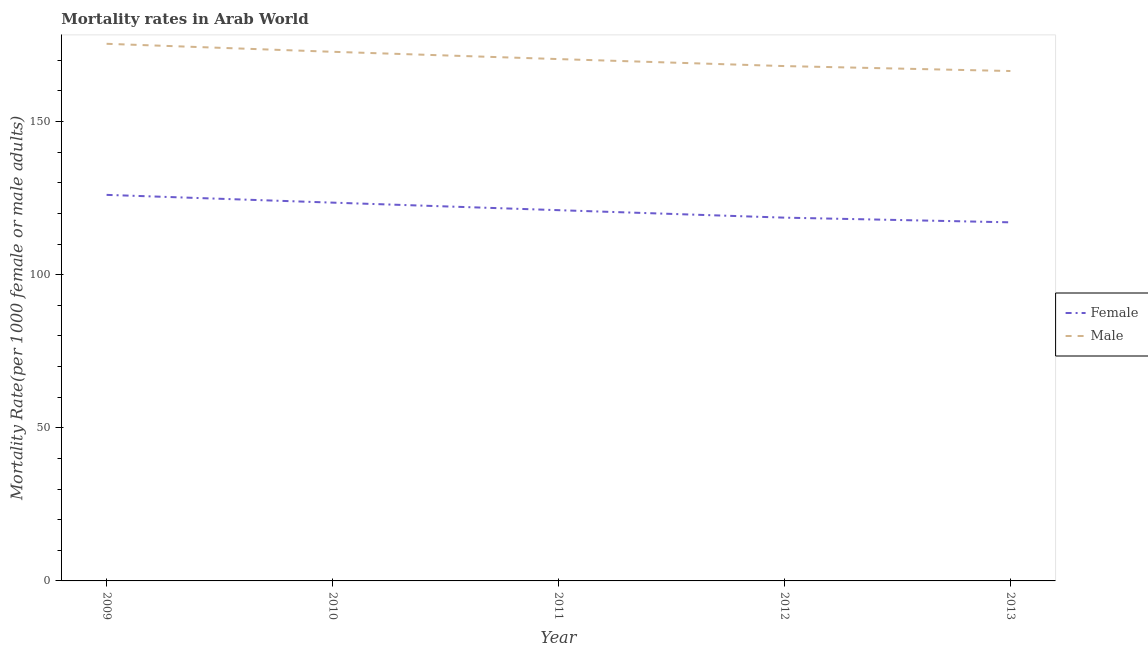What is the male mortality rate in 2012?
Give a very brief answer. 168.11. Across all years, what is the maximum female mortality rate?
Ensure brevity in your answer.  126.05. Across all years, what is the minimum female mortality rate?
Your response must be concise. 117.09. In which year was the male mortality rate minimum?
Give a very brief answer. 2013. What is the total male mortality rate in the graph?
Offer a very short reply. 853.14. What is the difference between the male mortality rate in 2009 and that in 2013?
Make the answer very short. 8.89. What is the difference between the male mortality rate in 2013 and the female mortality rate in 2009?
Ensure brevity in your answer.  40.44. What is the average female mortality rate per year?
Your answer should be compact. 121.27. In the year 2010, what is the difference between the female mortality rate and male mortality rate?
Provide a short and direct response. -49.25. What is the ratio of the female mortality rate in 2009 to that in 2012?
Your response must be concise. 1.06. Is the difference between the male mortality rate in 2010 and 2013 greater than the difference between the female mortality rate in 2010 and 2013?
Provide a succinct answer. No. What is the difference between the highest and the second highest male mortality rate?
Your response must be concise. 2.61. What is the difference between the highest and the lowest male mortality rate?
Offer a terse response. 8.89. Is the sum of the male mortality rate in 2009 and 2010 greater than the maximum female mortality rate across all years?
Your response must be concise. Yes. Does the male mortality rate monotonically increase over the years?
Keep it short and to the point. No. Is the female mortality rate strictly greater than the male mortality rate over the years?
Offer a very short reply. No. Is the male mortality rate strictly less than the female mortality rate over the years?
Keep it short and to the point. No. Does the graph contain any zero values?
Make the answer very short. No. Does the graph contain grids?
Make the answer very short. No. How many legend labels are there?
Keep it short and to the point. 2. How are the legend labels stacked?
Offer a very short reply. Vertical. What is the title of the graph?
Offer a terse response. Mortality rates in Arab World. What is the label or title of the X-axis?
Keep it short and to the point. Year. What is the label or title of the Y-axis?
Your answer should be very brief. Mortality Rate(per 1000 female or male adults). What is the Mortality Rate(per 1000 female or male adults) in Female in 2009?
Give a very brief answer. 126.05. What is the Mortality Rate(per 1000 female or male adults) of Male in 2009?
Ensure brevity in your answer.  175.38. What is the Mortality Rate(per 1000 female or male adults) in Female in 2010?
Your answer should be very brief. 123.52. What is the Mortality Rate(per 1000 female or male adults) of Male in 2010?
Offer a very short reply. 172.77. What is the Mortality Rate(per 1000 female or male adults) in Female in 2011?
Your response must be concise. 121.06. What is the Mortality Rate(per 1000 female or male adults) in Male in 2011?
Your response must be concise. 170.39. What is the Mortality Rate(per 1000 female or male adults) in Female in 2012?
Keep it short and to the point. 118.62. What is the Mortality Rate(per 1000 female or male adults) in Male in 2012?
Your answer should be compact. 168.11. What is the Mortality Rate(per 1000 female or male adults) in Female in 2013?
Provide a short and direct response. 117.09. What is the Mortality Rate(per 1000 female or male adults) of Male in 2013?
Offer a terse response. 166.49. Across all years, what is the maximum Mortality Rate(per 1000 female or male adults) in Female?
Offer a very short reply. 126.05. Across all years, what is the maximum Mortality Rate(per 1000 female or male adults) of Male?
Your answer should be compact. 175.38. Across all years, what is the minimum Mortality Rate(per 1000 female or male adults) in Female?
Give a very brief answer. 117.09. Across all years, what is the minimum Mortality Rate(per 1000 female or male adults) of Male?
Offer a terse response. 166.49. What is the total Mortality Rate(per 1000 female or male adults) of Female in the graph?
Offer a very short reply. 606.33. What is the total Mortality Rate(per 1000 female or male adults) of Male in the graph?
Make the answer very short. 853.14. What is the difference between the Mortality Rate(per 1000 female or male adults) in Female in 2009 and that in 2010?
Ensure brevity in your answer.  2.53. What is the difference between the Mortality Rate(per 1000 female or male adults) of Male in 2009 and that in 2010?
Your answer should be very brief. 2.61. What is the difference between the Mortality Rate(per 1000 female or male adults) of Female in 2009 and that in 2011?
Your answer should be compact. 5. What is the difference between the Mortality Rate(per 1000 female or male adults) in Male in 2009 and that in 2011?
Your response must be concise. 4.99. What is the difference between the Mortality Rate(per 1000 female or male adults) of Female in 2009 and that in 2012?
Your answer should be very brief. 7.44. What is the difference between the Mortality Rate(per 1000 female or male adults) of Male in 2009 and that in 2012?
Provide a short and direct response. 7.27. What is the difference between the Mortality Rate(per 1000 female or male adults) in Female in 2009 and that in 2013?
Your answer should be compact. 8.96. What is the difference between the Mortality Rate(per 1000 female or male adults) in Male in 2009 and that in 2013?
Your answer should be compact. 8.89. What is the difference between the Mortality Rate(per 1000 female or male adults) of Female in 2010 and that in 2011?
Provide a short and direct response. 2.46. What is the difference between the Mortality Rate(per 1000 female or male adults) of Male in 2010 and that in 2011?
Give a very brief answer. 2.38. What is the difference between the Mortality Rate(per 1000 female or male adults) in Female in 2010 and that in 2012?
Your response must be concise. 4.9. What is the difference between the Mortality Rate(per 1000 female or male adults) in Male in 2010 and that in 2012?
Your response must be concise. 4.67. What is the difference between the Mortality Rate(per 1000 female or male adults) of Female in 2010 and that in 2013?
Make the answer very short. 6.43. What is the difference between the Mortality Rate(per 1000 female or male adults) of Male in 2010 and that in 2013?
Offer a very short reply. 6.28. What is the difference between the Mortality Rate(per 1000 female or male adults) in Female in 2011 and that in 2012?
Your answer should be very brief. 2.44. What is the difference between the Mortality Rate(per 1000 female or male adults) in Male in 2011 and that in 2012?
Your answer should be very brief. 2.28. What is the difference between the Mortality Rate(per 1000 female or male adults) of Female in 2011 and that in 2013?
Your answer should be very brief. 3.97. What is the difference between the Mortality Rate(per 1000 female or male adults) in Male in 2011 and that in 2013?
Offer a very short reply. 3.9. What is the difference between the Mortality Rate(per 1000 female or male adults) of Female in 2012 and that in 2013?
Offer a very short reply. 1.53. What is the difference between the Mortality Rate(per 1000 female or male adults) in Male in 2012 and that in 2013?
Your response must be concise. 1.61. What is the difference between the Mortality Rate(per 1000 female or male adults) of Female in 2009 and the Mortality Rate(per 1000 female or male adults) of Male in 2010?
Offer a terse response. -46.72. What is the difference between the Mortality Rate(per 1000 female or male adults) in Female in 2009 and the Mortality Rate(per 1000 female or male adults) in Male in 2011?
Offer a very short reply. -44.34. What is the difference between the Mortality Rate(per 1000 female or male adults) in Female in 2009 and the Mortality Rate(per 1000 female or male adults) in Male in 2012?
Your answer should be compact. -42.05. What is the difference between the Mortality Rate(per 1000 female or male adults) in Female in 2009 and the Mortality Rate(per 1000 female or male adults) in Male in 2013?
Your answer should be very brief. -40.44. What is the difference between the Mortality Rate(per 1000 female or male adults) in Female in 2010 and the Mortality Rate(per 1000 female or male adults) in Male in 2011?
Provide a succinct answer. -46.87. What is the difference between the Mortality Rate(per 1000 female or male adults) in Female in 2010 and the Mortality Rate(per 1000 female or male adults) in Male in 2012?
Your answer should be very brief. -44.59. What is the difference between the Mortality Rate(per 1000 female or male adults) in Female in 2010 and the Mortality Rate(per 1000 female or male adults) in Male in 2013?
Provide a succinct answer. -42.97. What is the difference between the Mortality Rate(per 1000 female or male adults) in Female in 2011 and the Mortality Rate(per 1000 female or male adults) in Male in 2012?
Your answer should be very brief. -47.05. What is the difference between the Mortality Rate(per 1000 female or male adults) in Female in 2011 and the Mortality Rate(per 1000 female or male adults) in Male in 2013?
Your answer should be compact. -45.44. What is the difference between the Mortality Rate(per 1000 female or male adults) in Female in 2012 and the Mortality Rate(per 1000 female or male adults) in Male in 2013?
Provide a short and direct response. -47.88. What is the average Mortality Rate(per 1000 female or male adults) in Female per year?
Your response must be concise. 121.27. What is the average Mortality Rate(per 1000 female or male adults) of Male per year?
Your answer should be compact. 170.63. In the year 2009, what is the difference between the Mortality Rate(per 1000 female or male adults) in Female and Mortality Rate(per 1000 female or male adults) in Male?
Provide a succinct answer. -49.33. In the year 2010, what is the difference between the Mortality Rate(per 1000 female or male adults) of Female and Mortality Rate(per 1000 female or male adults) of Male?
Your answer should be very brief. -49.25. In the year 2011, what is the difference between the Mortality Rate(per 1000 female or male adults) in Female and Mortality Rate(per 1000 female or male adults) in Male?
Your response must be concise. -49.33. In the year 2012, what is the difference between the Mortality Rate(per 1000 female or male adults) in Female and Mortality Rate(per 1000 female or male adults) in Male?
Keep it short and to the point. -49.49. In the year 2013, what is the difference between the Mortality Rate(per 1000 female or male adults) of Female and Mortality Rate(per 1000 female or male adults) of Male?
Provide a short and direct response. -49.4. What is the ratio of the Mortality Rate(per 1000 female or male adults) of Female in 2009 to that in 2010?
Offer a very short reply. 1.02. What is the ratio of the Mortality Rate(per 1000 female or male adults) of Male in 2009 to that in 2010?
Your response must be concise. 1.02. What is the ratio of the Mortality Rate(per 1000 female or male adults) of Female in 2009 to that in 2011?
Provide a succinct answer. 1.04. What is the ratio of the Mortality Rate(per 1000 female or male adults) of Male in 2009 to that in 2011?
Provide a succinct answer. 1.03. What is the ratio of the Mortality Rate(per 1000 female or male adults) of Female in 2009 to that in 2012?
Offer a terse response. 1.06. What is the ratio of the Mortality Rate(per 1000 female or male adults) of Male in 2009 to that in 2012?
Give a very brief answer. 1.04. What is the ratio of the Mortality Rate(per 1000 female or male adults) in Female in 2009 to that in 2013?
Your answer should be very brief. 1.08. What is the ratio of the Mortality Rate(per 1000 female or male adults) of Male in 2009 to that in 2013?
Make the answer very short. 1.05. What is the ratio of the Mortality Rate(per 1000 female or male adults) of Female in 2010 to that in 2011?
Provide a succinct answer. 1.02. What is the ratio of the Mortality Rate(per 1000 female or male adults) of Female in 2010 to that in 2012?
Your response must be concise. 1.04. What is the ratio of the Mortality Rate(per 1000 female or male adults) of Male in 2010 to that in 2012?
Keep it short and to the point. 1.03. What is the ratio of the Mortality Rate(per 1000 female or male adults) in Female in 2010 to that in 2013?
Make the answer very short. 1.05. What is the ratio of the Mortality Rate(per 1000 female or male adults) in Male in 2010 to that in 2013?
Give a very brief answer. 1.04. What is the ratio of the Mortality Rate(per 1000 female or male adults) of Female in 2011 to that in 2012?
Provide a short and direct response. 1.02. What is the ratio of the Mortality Rate(per 1000 female or male adults) of Male in 2011 to that in 2012?
Offer a very short reply. 1.01. What is the ratio of the Mortality Rate(per 1000 female or male adults) of Female in 2011 to that in 2013?
Offer a very short reply. 1.03. What is the ratio of the Mortality Rate(per 1000 female or male adults) of Male in 2011 to that in 2013?
Offer a very short reply. 1.02. What is the ratio of the Mortality Rate(per 1000 female or male adults) in Female in 2012 to that in 2013?
Your answer should be compact. 1.01. What is the ratio of the Mortality Rate(per 1000 female or male adults) in Male in 2012 to that in 2013?
Your response must be concise. 1.01. What is the difference between the highest and the second highest Mortality Rate(per 1000 female or male adults) in Female?
Your answer should be compact. 2.53. What is the difference between the highest and the second highest Mortality Rate(per 1000 female or male adults) in Male?
Provide a succinct answer. 2.61. What is the difference between the highest and the lowest Mortality Rate(per 1000 female or male adults) in Female?
Your answer should be compact. 8.96. What is the difference between the highest and the lowest Mortality Rate(per 1000 female or male adults) of Male?
Your response must be concise. 8.89. 